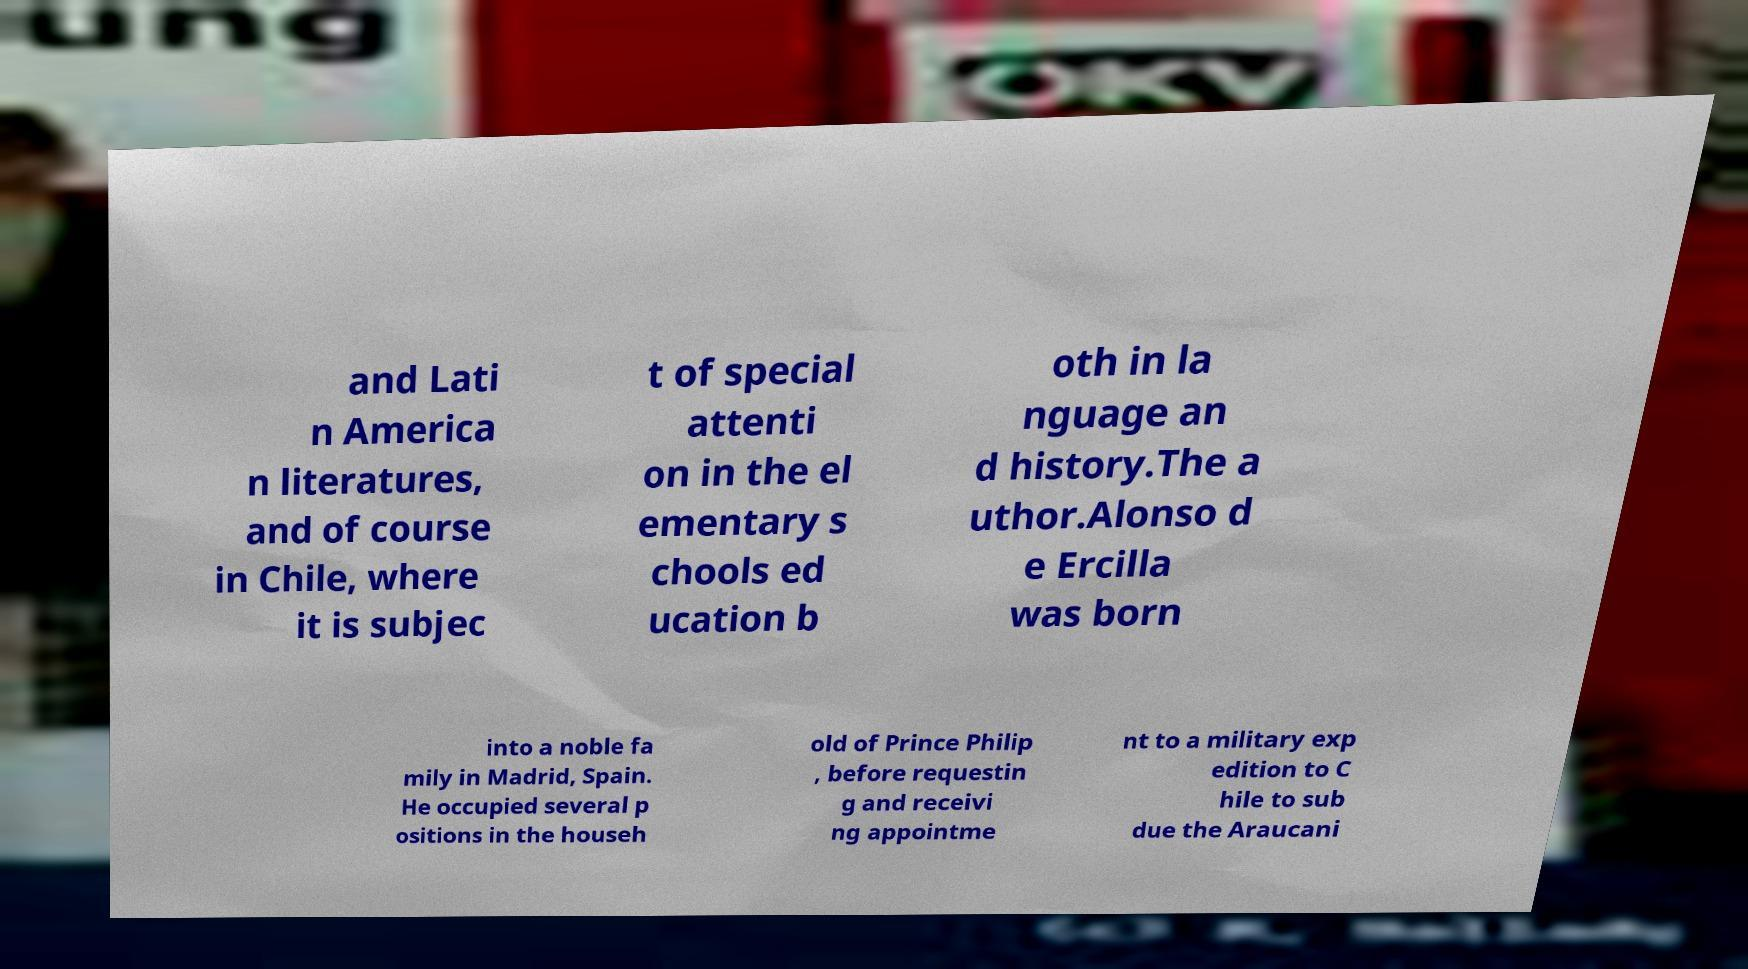What messages or text are displayed in this image? I need them in a readable, typed format. and Lati n America n literatures, and of course in Chile, where it is subjec t of special attenti on in the el ementary s chools ed ucation b oth in la nguage an d history.The a uthor.Alonso d e Ercilla was born into a noble fa mily in Madrid, Spain. He occupied several p ositions in the househ old of Prince Philip , before requestin g and receivi ng appointme nt to a military exp edition to C hile to sub due the Araucani 